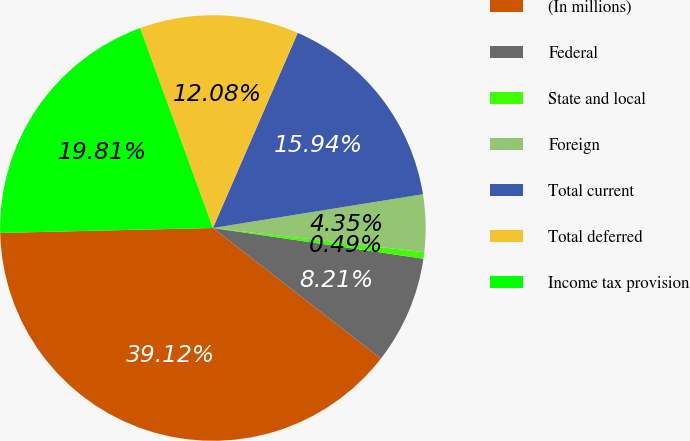Convert chart to OTSL. <chart><loc_0><loc_0><loc_500><loc_500><pie_chart><fcel>(In millions)<fcel>Federal<fcel>State and local<fcel>Foreign<fcel>Total current<fcel>Total deferred<fcel>Income tax provision<nl><fcel>39.12%<fcel>8.21%<fcel>0.49%<fcel>4.35%<fcel>15.94%<fcel>12.08%<fcel>19.81%<nl></chart> 